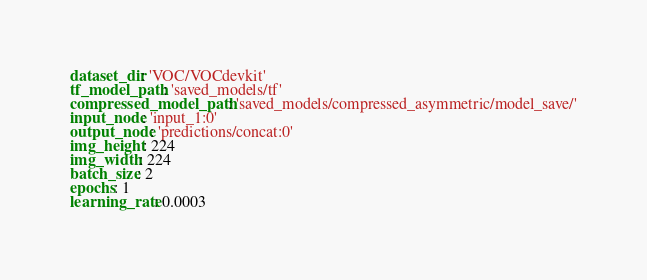<code> <loc_0><loc_0><loc_500><loc_500><_YAML_>dataset_dir: 'VOC/VOCdevkit'
tf_model_path: 'saved_models/tf'
compressed_model_path: 'saved_models/compressed_asymmetric/model_save/'
input_node: 'input_1:0'
output_node: 'predictions/concat:0'
img_height: 224
img_width: 224
batch_size: 2
epochs: 1
learning_rate: 0.0003
</code> 